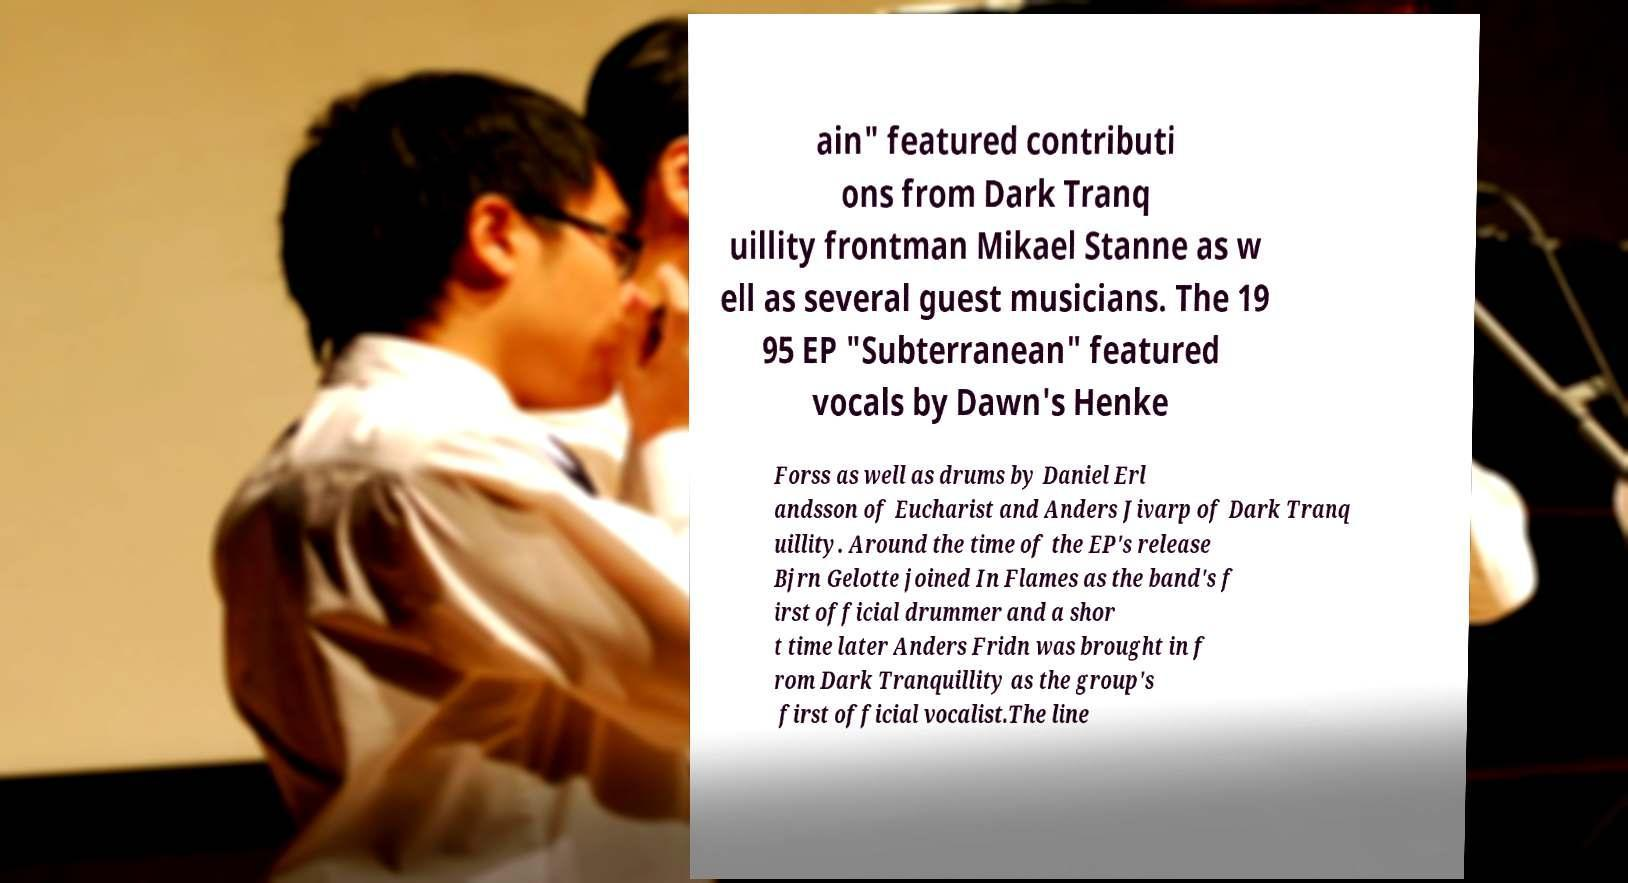What messages or text are displayed in this image? I need them in a readable, typed format. ain" featured contributi ons from Dark Tranq uillity frontman Mikael Stanne as w ell as several guest musicians. The 19 95 EP "Subterranean" featured vocals by Dawn's Henke Forss as well as drums by Daniel Erl andsson of Eucharist and Anders Jivarp of Dark Tranq uillity. Around the time of the EP's release Bjrn Gelotte joined In Flames as the band's f irst official drummer and a shor t time later Anders Fridn was brought in f rom Dark Tranquillity as the group's first official vocalist.The line 